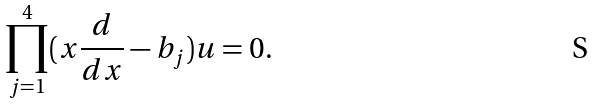<formula> <loc_0><loc_0><loc_500><loc_500>\prod _ { j = 1 } ^ { 4 } ( x \frac { d } { d x } - b _ { j } ) u = 0 .</formula> 